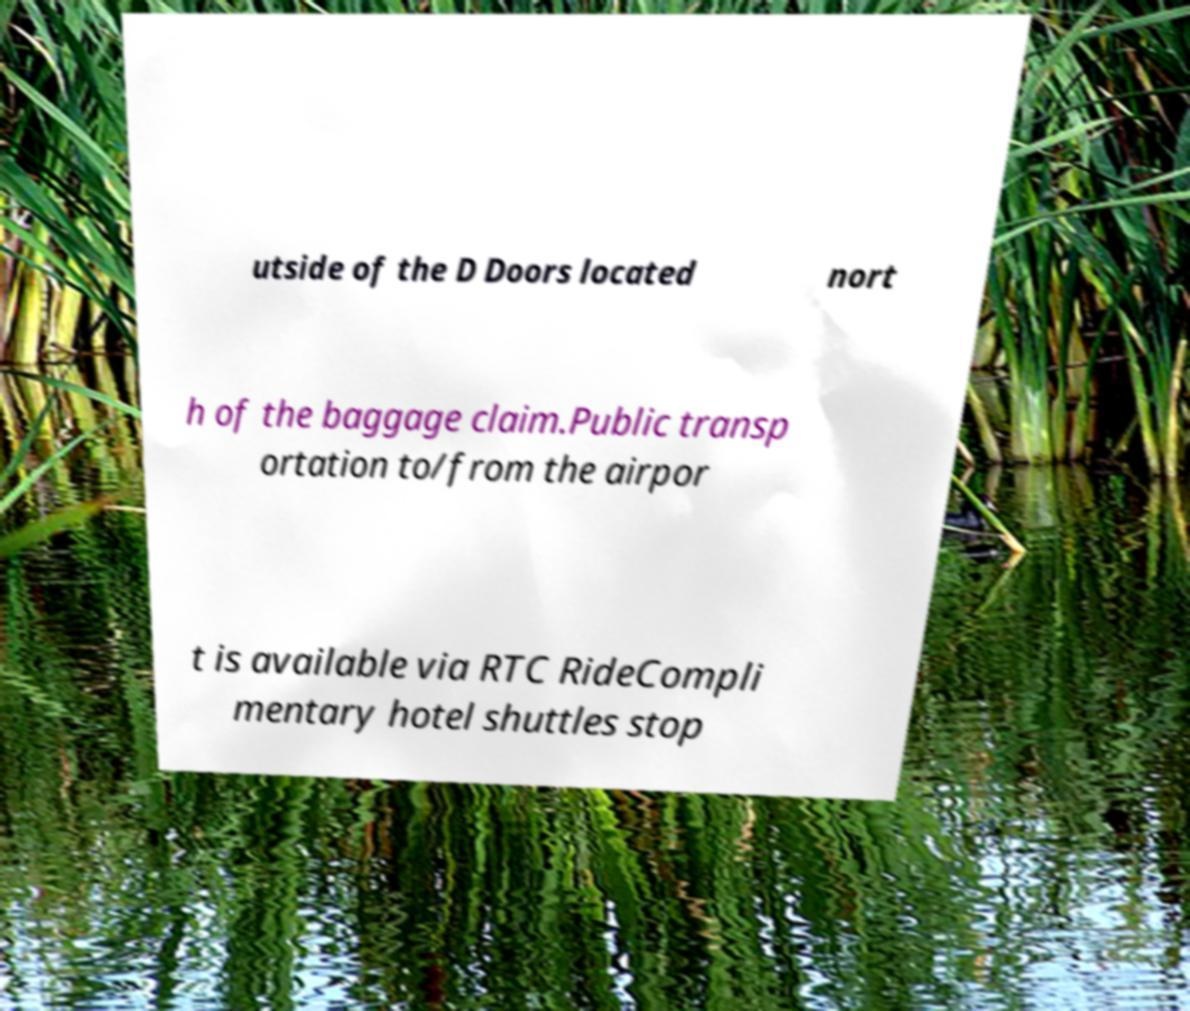Can you read and provide the text displayed in the image?This photo seems to have some interesting text. Can you extract and type it out for me? utside of the D Doors located nort h of the baggage claim.Public transp ortation to/from the airpor t is available via RTC RideCompli mentary hotel shuttles stop 